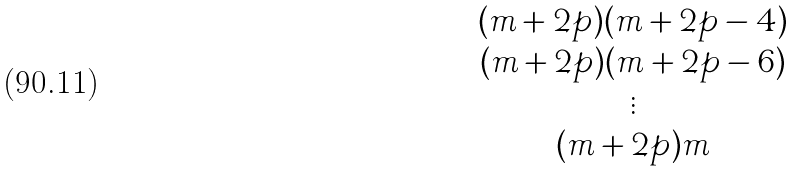<formula> <loc_0><loc_0><loc_500><loc_500>\begin{matrix} ( m + 2 p ) ( m + 2 p - 4 ) \\ ( m + 2 p ) ( m + 2 p - 6 ) \\ \vdots \\ ( m + 2 p ) m \end{matrix}</formula> 